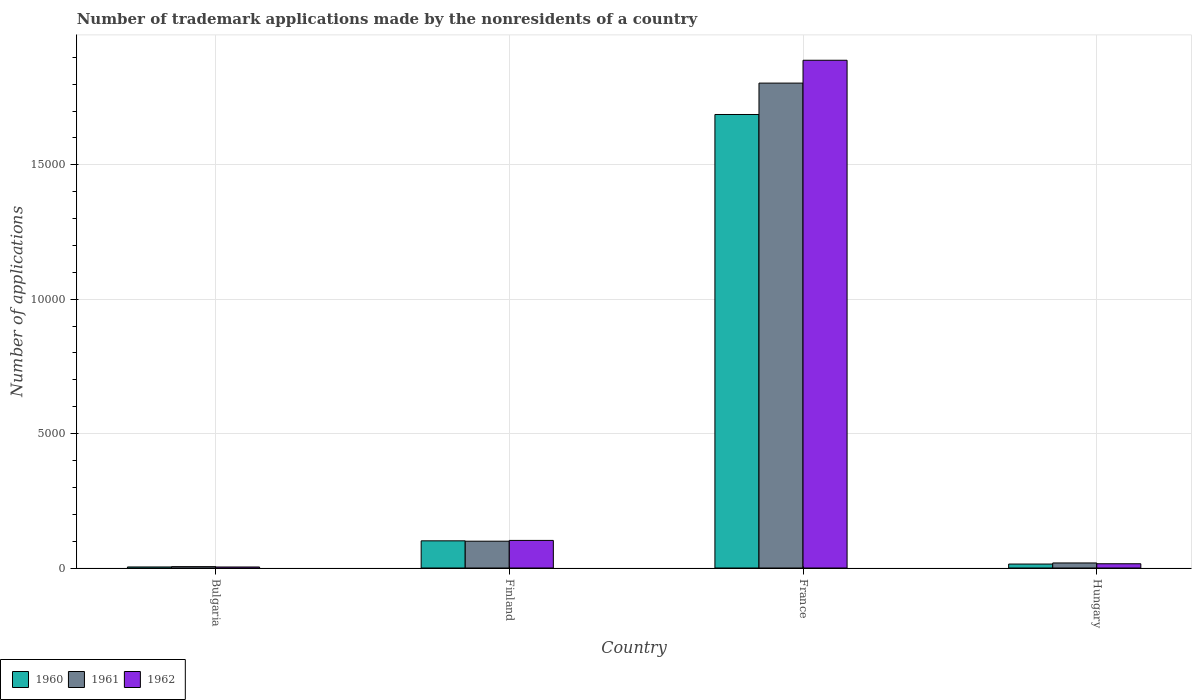How many groups of bars are there?
Make the answer very short. 4. Are the number of bars per tick equal to the number of legend labels?
Give a very brief answer. Yes. What is the label of the 4th group of bars from the left?
Your answer should be very brief. Hungary. What is the number of trademark applications made by the nonresidents in 1961 in Hungary?
Offer a terse response. 188. Across all countries, what is the maximum number of trademark applications made by the nonresidents in 1962?
Offer a terse response. 1.89e+04. Across all countries, what is the minimum number of trademark applications made by the nonresidents in 1960?
Provide a short and direct response. 39. In which country was the number of trademark applications made by the nonresidents in 1961 maximum?
Your response must be concise. France. In which country was the number of trademark applications made by the nonresidents in 1960 minimum?
Give a very brief answer. Bulgaria. What is the total number of trademark applications made by the nonresidents in 1961 in the graph?
Your response must be concise. 1.93e+04. What is the difference between the number of trademark applications made by the nonresidents in 1960 in Finland and that in Hungary?
Ensure brevity in your answer.  864. What is the difference between the number of trademark applications made by the nonresidents in 1962 in France and the number of trademark applications made by the nonresidents in 1960 in Bulgaria?
Give a very brief answer. 1.89e+04. What is the average number of trademark applications made by the nonresidents in 1962 per country?
Give a very brief answer. 5028.75. What is the difference between the number of trademark applications made by the nonresidents of/in 1960 and number of trademark applications made by the nonresidents of/in 1962 in Finland?
Keep it short and to the point. -16. What is the ratio of the number of trademark applications made by the nonresidents in 1961 in Bulgaria to that in Hungary?
Your response must be concise. 0.27. Is the difference between the number of trademark applications made by the nonresidents in 1960 in France and Hungary greater than the difference between the number of trademark applications made by the nonresidents in 1962 in France and Hungary?
Provide a short and direct response. No. What is the difference between the highest and the second highest number of trademark applications made by the nonresidents in 1962?
Your answer should be very brief. -1.79e+04. What is the difference between the highest and the lowest number of trademark applications made by the nonresidents in 1960?
Provide a succinct answer. 1.68e+04. In how many countries, is the number of trademark applications made by the nonresidents in 1960 greater than the average number of trademark applications made by the nonresidents in 1960 taken over all countries?
Your answer should be compact. 1. Is the sum of the number of trademark applications made by the nonresidents in 1960 in Bulgaria and France greater than the maximum number of trademark applications made by the nonresidents in 1962 across all countries?
Your response must be concise. No. What does the 1st bar from the left in France represents?
Provide a short and direct response. 1960. What is the difference between two consecutive major ticks on the Y-axis?
Make the answer very short. 5000. Does the graph contain grids?
Your answer should be compact. Yes. Where does the legend appear in the graph?
Give a very brief answer. Bottom left. How many legend labels are there?
Your answer should be compact. 3. What is the title of the graph?
Provide a short and direct response. Number of trademark applications made by the nonresidents of a country. Does "1989" appear as one of the legend labels in the graph?
Your response must be concise. No. What is the label or title of the Y-axis?
Your response must be concise. Number of applications. What is the Number of applications in 1960 in Bulgaria?
Your answer should be compact. 39. What is the Number of applications in 1960 in Finland?
Keep it short and to the point. 1011. What is the Number of applications of 1961 in Finland?
Provide a short and direct response. 998. What is the Number of applications in 1962 in Finland?
Your answer should be very brief. 1027. What is the Number of applications in 1960 in France?
Keep it short and to the point. 1.69e+04. What is the Number of applications in 1961 in France?
Make the answer very short. 1.80e+04. What is the Number of applications of 1962 in France?
Your answer should be very brief. 1.89e+04. What is the Number of applications in 1960 in Hungary?
Offer a very short reply. 147. What is the Number of applications of 1961 in Hungary?
Your answer should be very brief. 188. What is the Number of applications of 1962 in Hungary?
Offer a very short reply. 158. Across all countries, what is the maximum Number of applications of 1960?
Your answer should be compact. 1.69e+04. Across all countries, what is the maximum Number of applications in 1961?
Give a very brief answer. 1.80e+04. Across all countries, what is the maximum Number of applications in 1962?
Keep it short and to the point. 1.89e+04. Across all countries, what is the minimum Number of applications in 1960?
Provide a short and direct response. 39. Across all countries, what is the minimum Number of applications of 1962?
Provide a short and direct response. 38. What is the total Number of applications of 1960 in the graph?
Your response must be concise. 1.81e+04. What is the total Number of applications in 1961 in the graph?
Make the answer very short. 1.93e+04. What is the total Number of applications of 1962 in the graph?
Your answer should be very brief. 2.01e+04. What is the difference between the Number of applications in 1960 in Bulgaria and that in Finland?
Give a very brief answer. -972. What is the difference between the Number of applications of 1961 in Bulgaria and that in Finland?
Offer a terse response. -947. What is the difference between the Number of applications of 1962 in Bulgaria and that in Finland?
Your answer should be compact. -989. What is the difference between the Number of applications in 1960 in Bulgaria and that in France?
Give a very brief answer. -1.68e+04. What is the difference between the Number of applications of 1961 in Bulgaria and that in France?
Keep it short and to the point. -1.80e+04. What is the difference between the Number of applications in 1962 in Bulgaria and that in France?
Provide a succinct answer. -1.89e+04. What is the difference between the Number of applications of 1960 in Bulgaria and that in Hungary?
Your answer should be compact. -108. What is the difference between the Number of applications in 1961 in Bulgaria and that in Hungary?
Provide a succinct answer. -137. What is the difference between the Number of applications of 1962 in Bulgaria and that in Hungary?
Provide a short and direct response. -120. What is the difference between the Number of applications in 1960 in Finland and that in France?
Ensure brevity in your answer.  -1.59e+04. What is the difference between the Number of applications in 1961 in Finland and that in France?
Ensure brevity in your answer.  -1.70e+04. What is the difference between the Number of applications of 1962 in Finland and that in France?
Provide a short and direct response. -1.79e+04. What is the difference between the Number of applications of 1960 in Finland and that in Hungary?
Provide a succinct answer. 864. What is the difference between the Number of applications in 1961 in Finland and that in Hungary?
Provide a short and direct response. 810. What is the difference between the Number of applications of 1962 in Finland and that in Hungary?
Offer a very short reply. 869. What is the difference between the Number of applications of 1960 in France and that in Hungary?
Provide a short and direct response. 1.67e+04. What is the difference between the Number of applications of 1961 in France and that in Hungary?
Offer a very short reply. 1.79e+04. What is the difference between the Number of applications of 1962 in France and that in Hungary?
Ensure brevity in your answer.  1.87e+04. What is the difference between the Number of applications in 1960 in Bulgaria and the Number of applications in 1961 in Finland?
Ensure brevity in your answer.  -959. What is the difference between the Number of applications of 1960 in Bulgaria and the Number of applications of 1962 in Finland?
Provide a succinct answer. -988. What is the difference between the Number of applications in 1961 in Bulgaria and the Number of applications in 1962 in Finland?
Your answer should be compact. -976. What is the difference between the Number of applications of 1960 in Bulgaria and the Number of applications of 1961 in France?
Offer a terse response. -1.80e+04. What is the difference between the Number of applications in 1960 in Bulgaria and the Number of applications in 1962 in France?
Your answer should be very brief. -1.89e+04. What is the difference between the Number of applications of 1961 in Bulgaria and the Number of applications of 1962 in France?
Give a very brief answer. -1.88e+04. What is the difference between the Number of applications in 1960 in Bulgaria and the Number of applications in 1961 in Hungary?
Your response must be concise. -149. What is the difference between the Number of applications in 1960 in Bulgaria and the Number of applications in 1962 in Hungary?
Ensure brevity in your answer.  -119. What is the difference between the Number of applications in 1961 in Bulgaria and the Number of applications in 1962 in Hungary?
Ensure brevity in your answer.  -107. What is the difference between the Number of applications in 1960 in Finland and the Number of applications in 1961 in France?
Offer a very short reply. -1.70e+04. What is the difference between the Number of applications in 1960 in Finland and the Number of applications in 1962 in France?
Make the answer very short. -1.79e+04. What is the difference between the Number of applications of 1961 in Finland and the Number of applications of 1962 in France?
Your response must be concise. -1.79e+04. What is the difference between the Number of applications in 1960 in Finland and the Number of applications in 1961 in Hungary?
Give a very brief answer. 823. What is the difference between the Number of applications of 1960 in Finland and the Number of applications of 1962 in Hungary?
Give a very brief answer. 853. What is the difference between the Number of applications of 1961 in Finland and the Number of applications of 1962 in Hungary?
Your answer should be very brief. 840. What is the difference between the Number of applications of 1960 in France and the Number of applications of 1961 in Hungary?
Give a very brief answer. 1.67e+04. What is the difference between the Number of applications in 1960 in France and the Number of applications in 1962 in Hungary?
Offer a terse response. 1.67e+04. What is the difference between the Number of applications of 1961 in France and the Number of applications of 1962 in Hungary?
Your response must be concise. 1.79e+04. What is the average Number of applications in 1960 per country?
Your answer should be compact. 4517.75. What is the average Number of applications in 1961 per country?
Ensure brevity in your answer.  4819.75. What is the average Number of applications in 1962 per country?
Provide a succinct answer. 5028.75. What is the difference between the Number of applications in 1960 and Number of applications in 1961 in Bulgaria?
Ensure brevity in your answer.  -12. What is the difference between the Number of applications of 1960 and Number of applications of 1962 in Bulgaria?
Give a very brief answer. 1. What is the difference between the Number of applications of 1961 and Number of applications of 1962 in Bulgaria?
Give a very brief answer. 13. What is the difference between the Number of applications of 1960 and Number of applications of 1962 in Finland?
Provide a short and direct response. -16. What is the difference between the Number of applications of 1960 and Number of applications of 1961 in France?
Keep it short and to the point. -1168. What is the difference between the Number of applications of 1960 and Number of applications of 1962 in France?
Make the answer very short. -2018. What is the difference between the Number of applications in 1961 and Number of applications in 1962 in France?
Your answer should be compact. -850. What is the difference between the Number of applications in 1960 and Number of applications in 1961 in Hungary?
Make the answer very short. -41. What is the difference between the Number of applications in 1961 and Number of applications in 1962 in Hungary?
Your response must be concise. 30. What is the ratio of the Number of applications in 1960 in Bulgaria to that in Finland?
Your answer should be compact. 0.04. What is the ratio of the Number of applications in 1961 in Bulgaria to that in Finland?
Give a very brief answer. 0.05. What is the ratio of the Number of applications of 1962 in Bulgaria to that in Finland?
Your answer should be compact. 0.04. What is the ratio of the Number of applications of 1960 in Bulgaria to that in France?
Ensure brevity in your answer.  0. What is the ratio of the Number of applications in 1961 in Bulgaria to that in France?
Your answer should be compact. 0. What is the ratio of the Number of applications in 1962 in Bulgaria to that in France?
Your answer should be very brief. 0. What is the ratio of the Number of applications in 1960 in Bulgaria to that in Hungary?
Make the answer very short. 0.27. What is the ratio of the Number of applications in 1961 in Bulgaria to that in Hungary?
Provide a succinct answer. 0.27. What is the ratio of the Number of applications in 1962 in Bulgaria to that in Hungary?
Provide a succinct answer. 0.24. What is the ratio of the Number of applications of 1960 in Finland to that in France?
Your answer should be very brief. 0.06. What is the ratio of the Number of applications in 1961 in Finland to that in France?
Give a very brief answer. 0.06. What is the ratio of the Number of applications in 1962 in Finland to that in France?
Give a very brief answer. 0.05. What is the ratio of the Number of applications of 1960 in Finland to that in Hungary?
Your answer should be compact. 6.88. What is the ratio of the Number of applications in 1961 in Finland to that in Hungary?
Your answer should be very brief. 5.31. What is the ratio of the Number of applications of 1960 in France to that in Hungary?
Ensure brevity in your answer.  114.79. What is the ratio of the Number of applications in 1961 in France to that in Hungary?
Offer a very short reply. 95.97. What is the ratio of the Number of applications in 1962 in France to that in Hungary?
Offer a very short reply. 119.57. What is the difference between the highest and the second highest Number of applications in 1960?
Keep it short and to the point. 1.59e+04. What is the difference between the highest and the second highest Number of applications of 1961?
Your answer should be compact. 1.70e+04. What is the difference between the highest and the second highest Number of applications in 1962?
Keep it short and to the point. 1.79e+04. What is the difference between the highest and the lowest Number of applications of 1960?
Provide a succinct answer. 1.68e+04. What is the difference between the highest and the lowest Number of applications of 1961?
Keep it short and to the point. 1.80e+04. What is the difference between the highest and the lowest Number of applications of 1962?
Offer a terse response. 1.89e+04. 